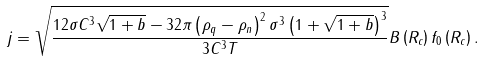Convert formula to latex. <formula><loc_0><loc_0><loc_500><loc_500>j = \sqrt { \frac { 1 2 \sigma C ^ { 3 } \sqrt { 1 + b } - 3 2 \pi \left ( \rho _ { q } - \rho _ { n } \right ) ^ { 2 } \sigma ^ { 3 } \left ( 1 + \sqrt { 1 + b } \right ) ^ { 3 } } { 3 C ^ { 3 } T } } B \left ( R _ { c } \right ) f _ { 0 } \left ( R _ { c } \right ) .</formula> 